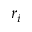<formula> <loc_0><loc_0><loc_500><loc_500>r _ { i }</formula> 